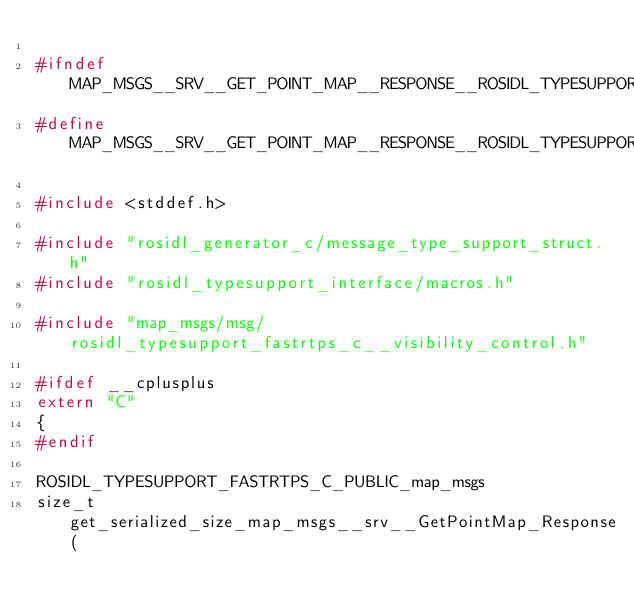Convert code to text. <code><loc_0><loc_0><loc_500><loc_500><_C_>
#ifndef MAP_MSGS__SRV__GET_POINT_MAP__RESPONSE__ROSIDL_TYPESUPPORT_FASTRTPS_C_H_
#define MAP_MSGS__SRV__GET_POINT_MAP__RESPONSE__ROSIDL_TYPESUPPORT_FASTRTPS_C_H_

#include <stddef.h>

#include "rosidl_generator_c/message_type_support_struct.h"
#include "rosidl_typesupport_interface/macros.h"

#include "map_msgs/msg/rosidl_typesupport_fastrtps_c__visibility_control.h"

#ifdef __cplusplus
extern "C"
{
#endif

ROSIDL_TYPESUPPORT_FASTRTPS_C_PUBLIC_map_msgs
size_t get_serialized_size_map_msgs__srv__GetPointMap_Response(</code> 